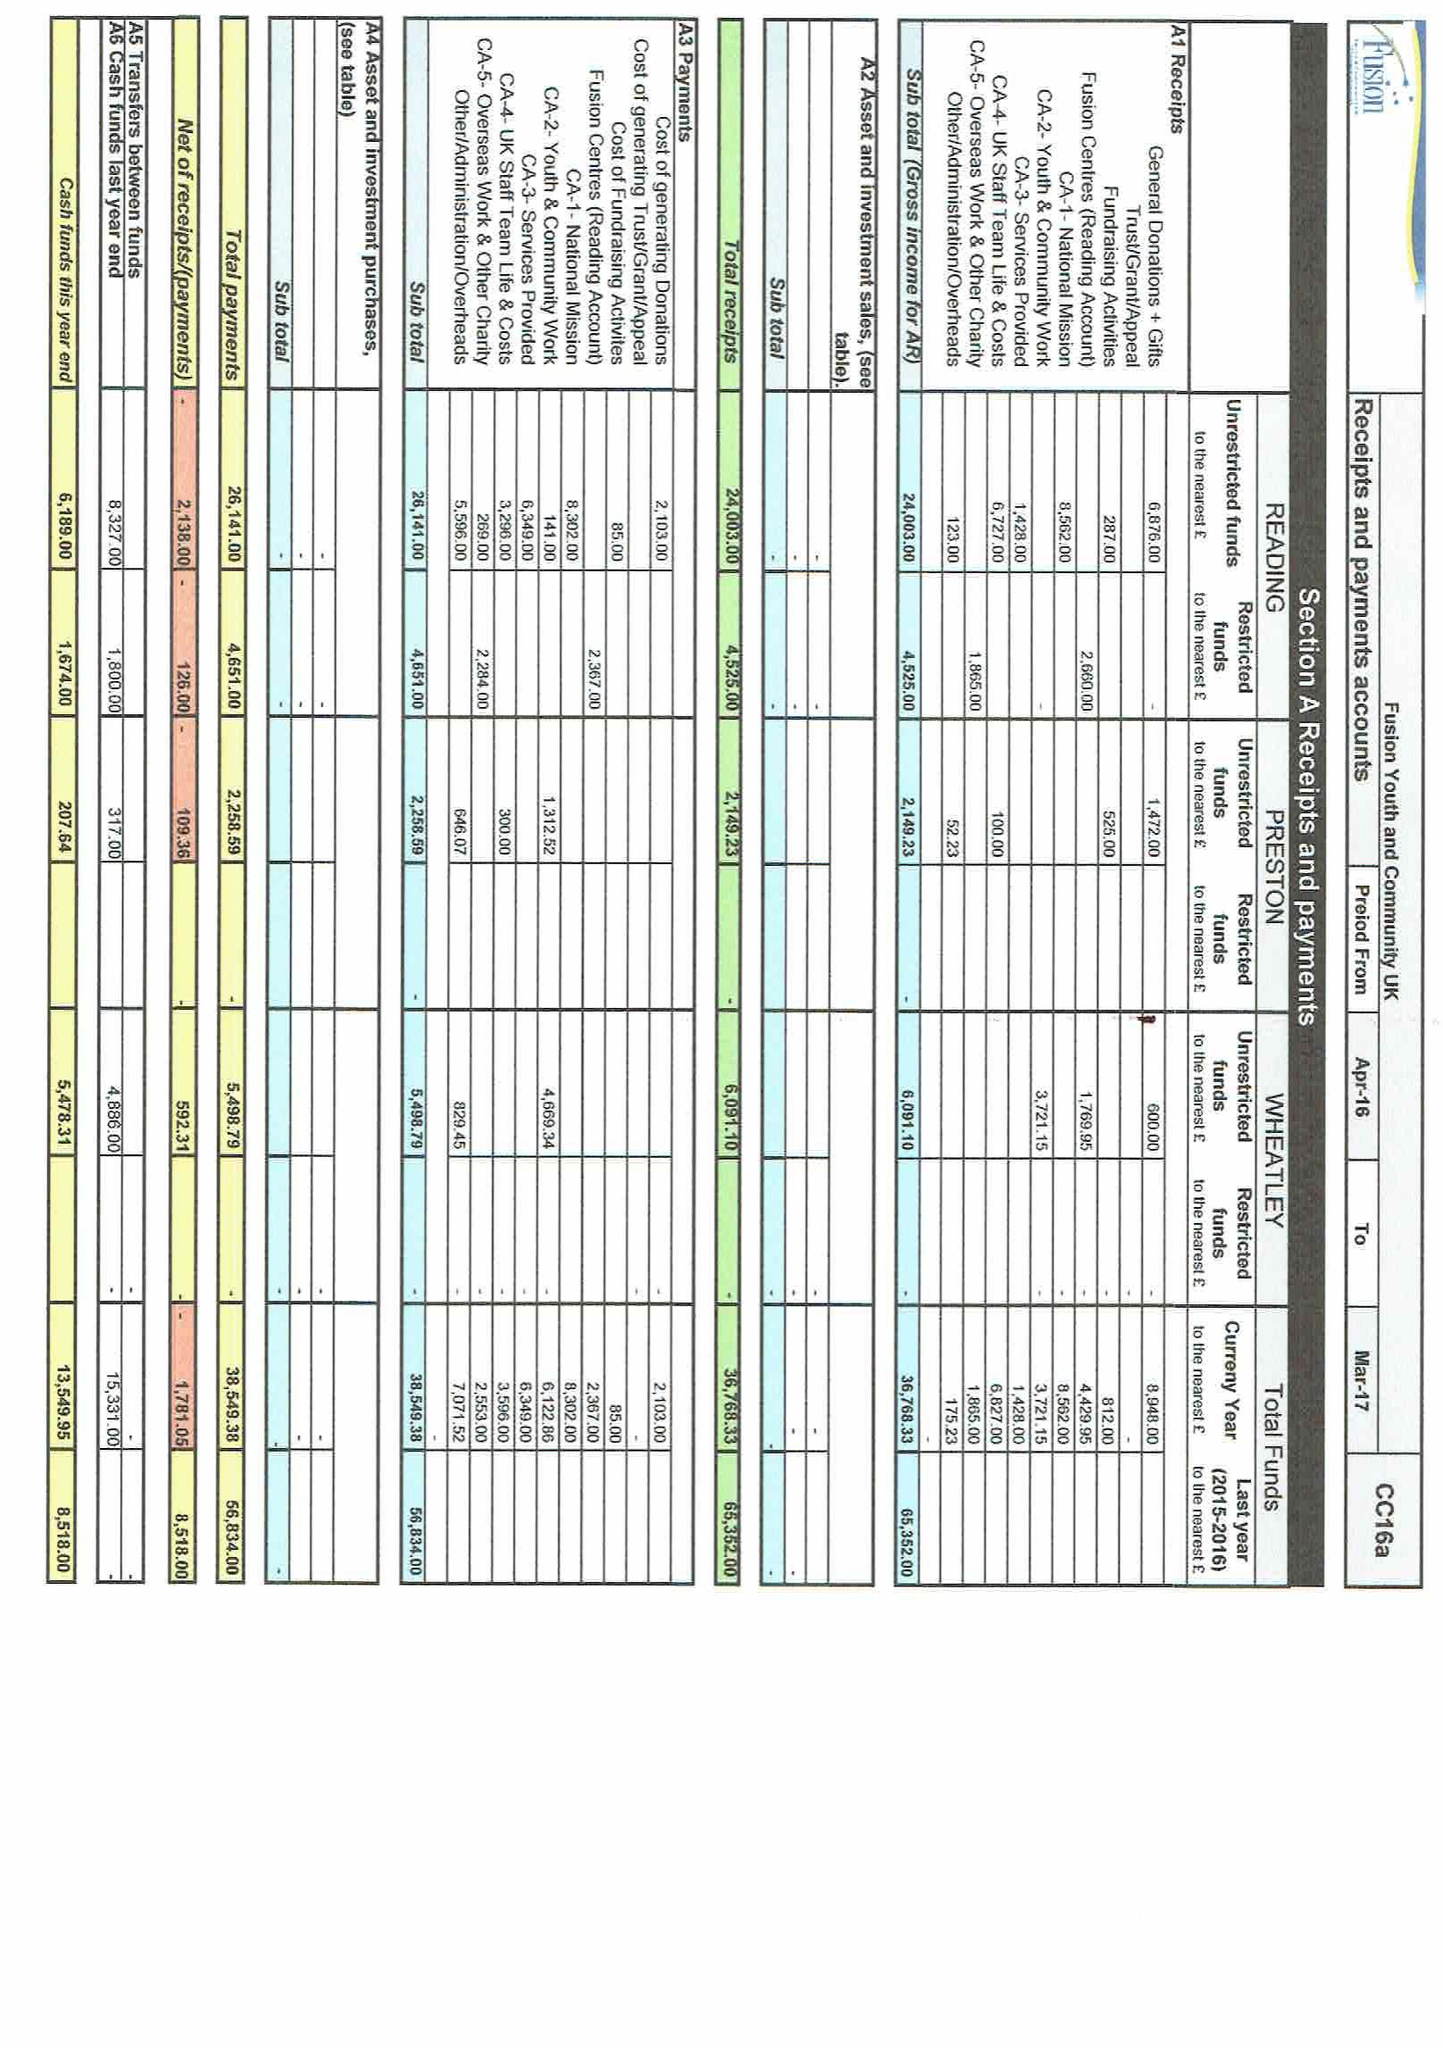What is the value for the address__post_town?
Answer the question using a single word or phrase. READING 